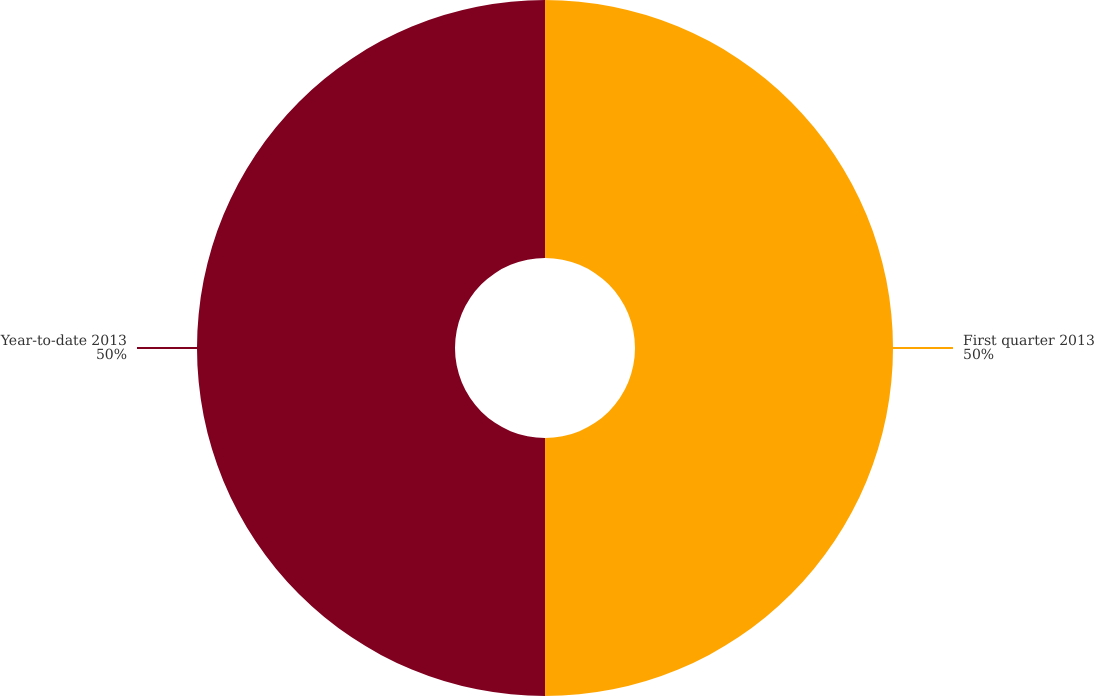<chart> <loc_0><loc_0><loc_500><loc_500><pie_chart><fcel>First quarter 2013<fcel>Year-to-date 2013<nl><fcel>50.0%<fcel>50.0%<nl></chart> 